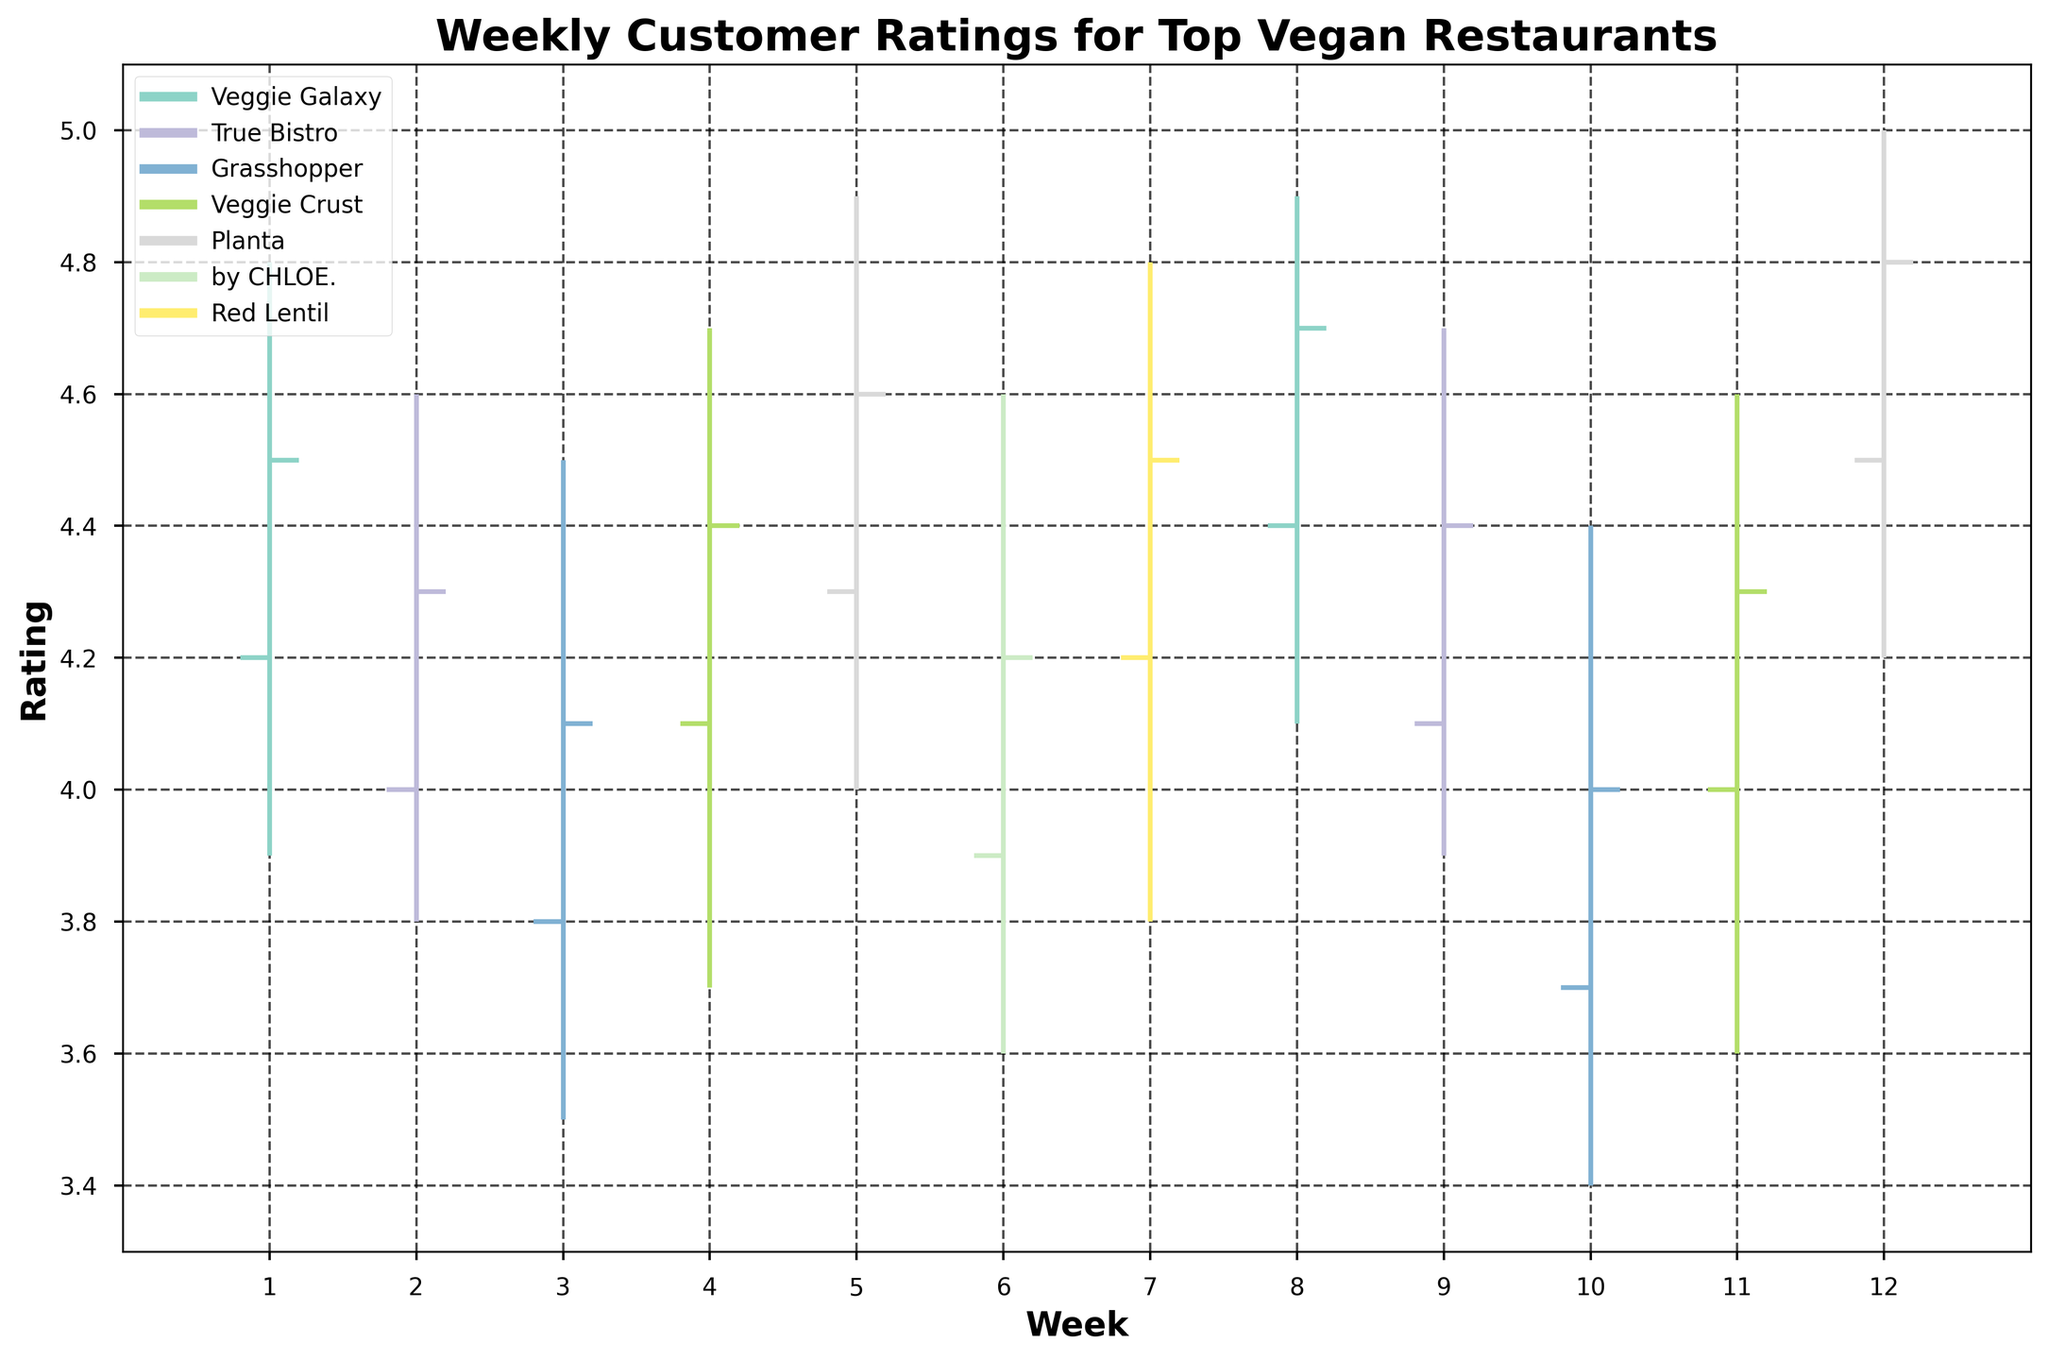What is the title of the chart? The title is usually located at the top of the chart and provides an overview of what the chart is about.
Answer: Weekly Customer Ratings for Top Vegan Restaurants What is the highest rating achieved by any restaurant in Week 5? Observing the OHLC chart, identify the peak point for Week 5, specifically looking at the 'High' value for that week.
Answer: 4.9 Which restaurant has the most consistent close ratings over the weeks? Consistency can be observed by checking how close the 'Close' values are across different weeks for each restaurant. Veggie Galaxy and Red Lentil have consistent closing values with minimal fluctuation.
Answer: Red Lentil What is the minimum 'Low' rating for True Bistro across all weeks? Locate all the 'Low' ratings for True Bistro across the chart and identify the smallest value.
Answer: 3.8 Which restaurant had the highest average 'Open' rating? Calculate the average 'Open' rating by summing all 'Open' ratings for each restaurant and dividing by the number of entries for that restaurant. Veggie Galaxy: (4.2 + 4.4)/2 = 4.3, True Bistro: (4.0 + 4.1)/2 = 4.05, Grasshopper: (3.8 + 3.7)/2 = 3.75, Veggie Crust: (4.1 + 4.0)/2 = 4.05, Planta: (4.3 + 4.5)/2 = 4.4, by CHLOE.: 3.9, Red Lentil: 4.2.
Answer: Planta with 4.4 Between Weeks 8 and 12, which restaurant had the highest peak rating? Examine the 'High' values for each restaurant between Weeks 8 and 12 and identify the maximum value. In Week 12, Planta had a 'High' value of 5.0.
Answer: Planta What is the range of the ratings (difference between High and Low) for Grasshopper in Week 3? Subtract the 'Low' value from the 'High' value for Grasshopper in Week 3. So, 4.5 - 3.5 = 1.0.
Answer: 1.0 Compare the closing ratings of True Bistro and Veggie Crust in Week 9. Which one is higher? Look at the 'Close' ratings for both True Bistro and Veggie Crust in Week 9 and compare them. True Bistro has a 'Close' of 4.4, while Veggie Crust has no data for Week 9.
Answer: True Bistro Which week had the highest variance in 'High' ratings among all restaurants? Identify the week where the spread between the highest 'High' rating and the lowest 'High' rating is the greatest. Week 12 varied between 5.0 (Planta) and other values.
Answer: Week 12 For by CHLOE., how many weeks had a 'Close' rating lower than 4.0? Count the number of weeks where by CHLOE.'s 'Close' rating is less than 4.0. by CHLOE has data for only Week 6 with Close of 4.2.
Answer: 0 